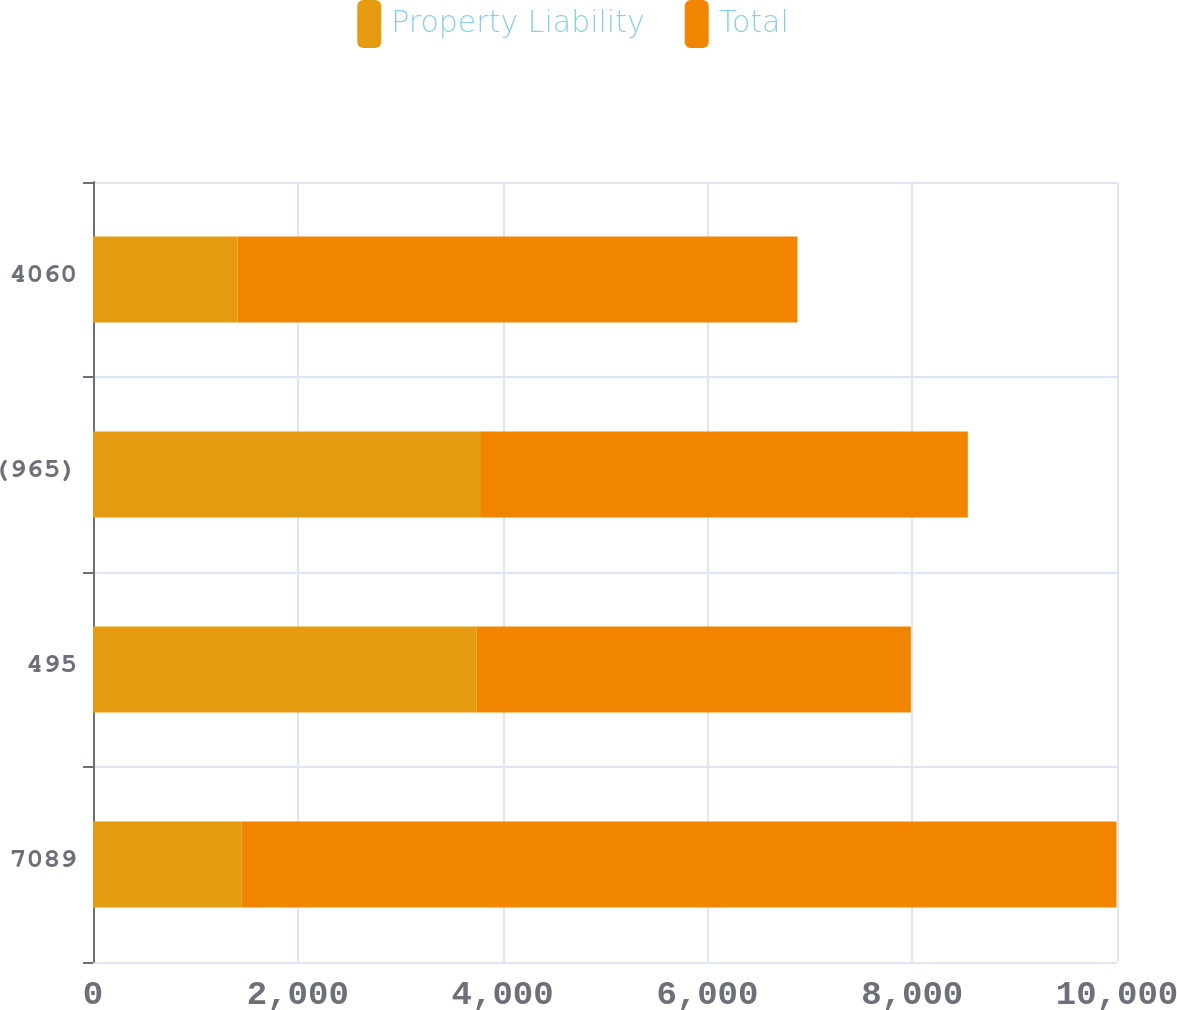Convert chart to OTSL. <chart><loc_0><loc_0><loc_500><loc_500><stacked_bar_chart><ecel><fcel>7089<fcel>495<fcel>(965)<fcel>4060<nl><fcel>Property Liability<fcel>1453<fcel>3746<fcel>3789<fcel>1410<nl><fcel>Total<fcel>8542<fcel>4241<fcel>4754<fcel>5470<nl></chart> 